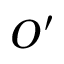Convert formula to latex. <formula><loc_0><loc_0><loc_500><loc_500>O ^ { \prime }</formula> 